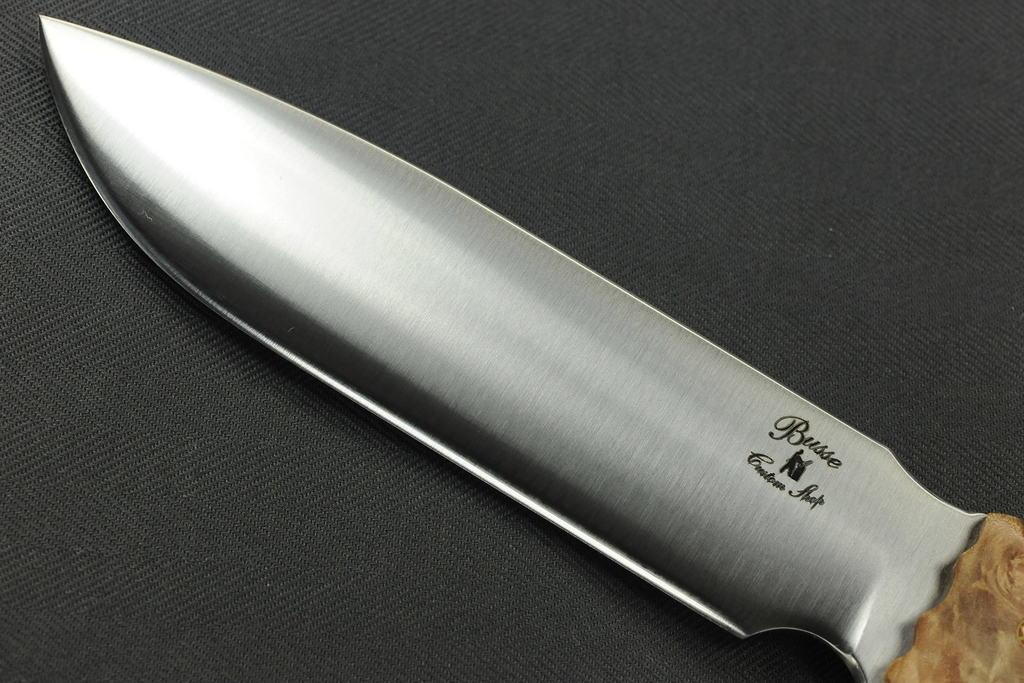What type of knife is in the image? There is a steel knife in the image. What is the knife placed on in the image? The knife is on a black surface. What type of news is being reported by the volcano in the image? There is no volcano or news present in the image; it only features a steel knife on a black surface. 